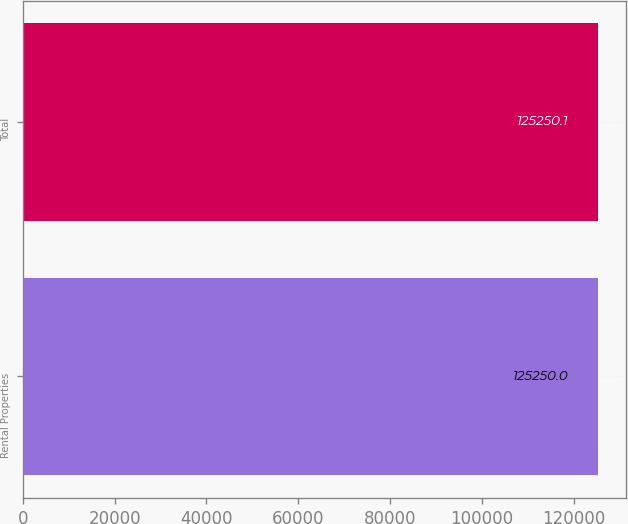Convert chart. <chart><loc_0><loc_0><loc_500><loc_500><bar_chart><fcel>Rental Properties<fcel>Total<nl><fcel>125250<fcel>125250<nl></chart> 